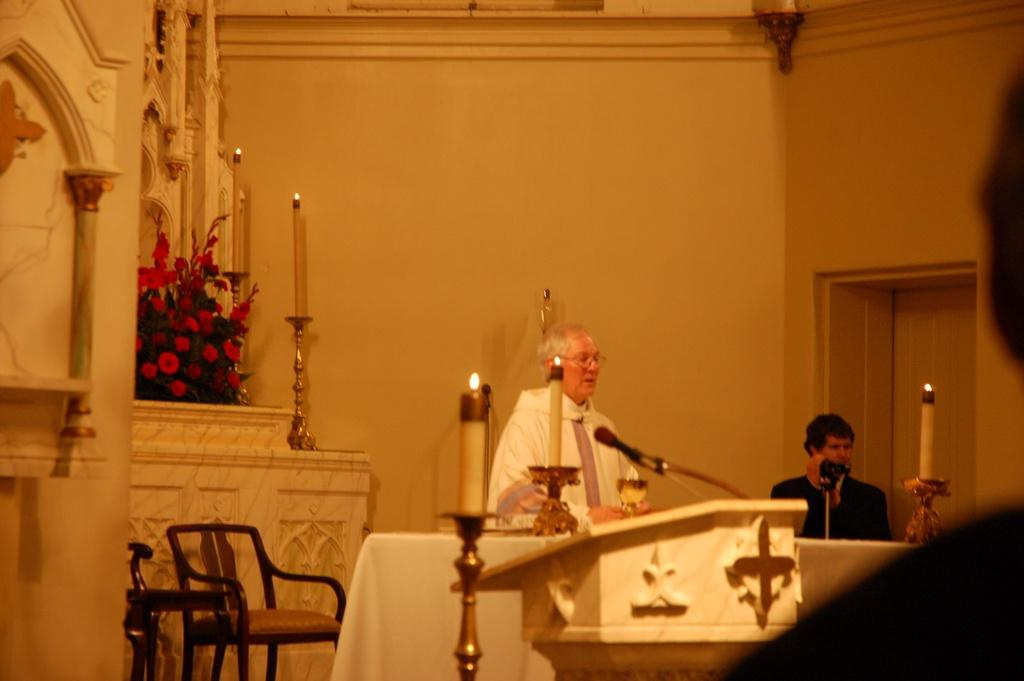What can be seen in the image involving people? There are people standing in the image. What objects are present that involve light? There are lighted candles on a stand in the image. What type of furniture is visible in the image? There are chairs in the image. What type of decoration can be seen in the image? There is a flower bouquet in the image. What type of alarm is ringing in the image? There is no alarm present or ringing in the image. What type of metal can be seen in the image? There is no specific metal object mentioned in the provided facts, so it cannot be determined from the image. 